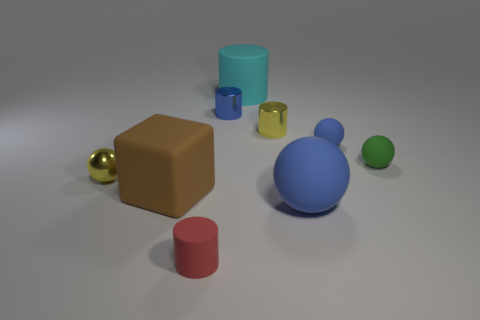Subtract all yellow metal spheres. How many spheres are left? 3 Subtract all blue spheres. How many spheres are left? 2 Subtract 2 balls. How many balls are left? 2 Subtract all blocks. How many objects are left? 8 Add 8 large blue matte objects. How many large blue matte objects exist? 9 Subtract 0 purple cylinders. How many objects are left? 9 Subtract all red cubes. Subtract all gray balls. How many cubes are left? 1 Subtract all red cylinders. How many green blocks are left? 0 Subtract all red things. Subtract all green rubber objects. How many objects are left? 7 Add 8 big rubber cylinders. How many big rubber cylinders are left? 9 